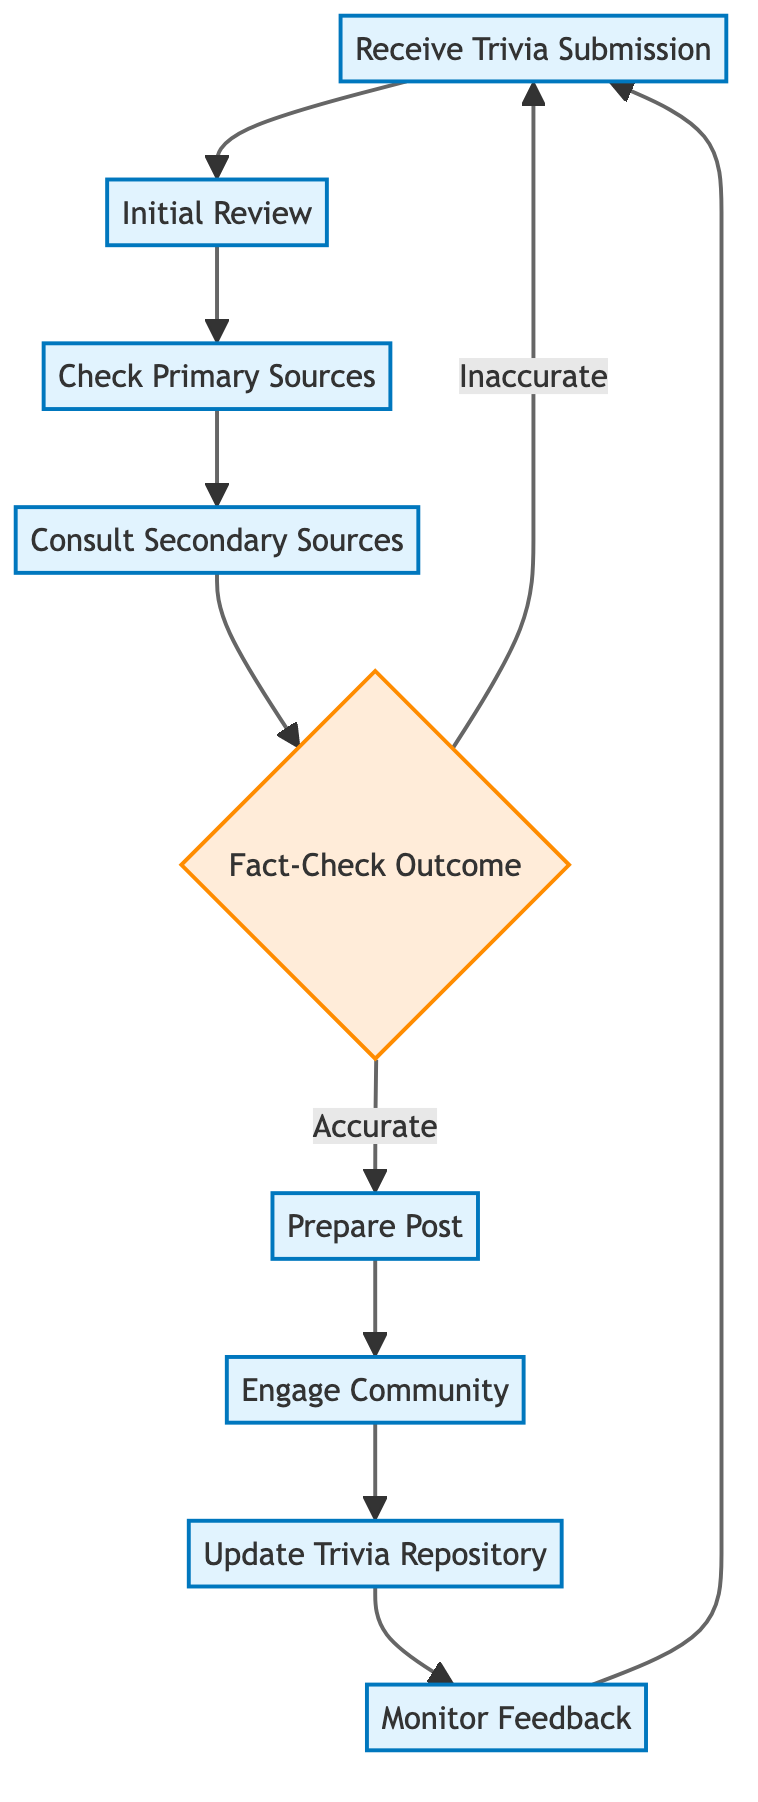What is the first step in the process? The first step in the process is "Receive Trivia Submission". This can be seen as the starting point in the flowchart where the process begins when moderators receive trivia submissions from forum members.
Answer: Receive Trivia Submission How many main process steps are there before the decision point? There are four main process steps before reaching the decision point labeled "Fact-Check Outcome". They are "Receive Trivia Submission", "Initial Review", "Check Primary Sources", and "Consult Secondary Sources".
Answer: Four What happens if the trivia submission is inaccurate? If the trivia submission is inaccurate, the flowchart indicates that the process loops back to "Receive Trivia Submission". This shows that moderators will provide feedback and request a resubmission from the member.
Answer: Return to Receive Trivia Submission What node follows "Prepare Post"? The node that follows "Prepare Post" is "Engage Community". This means after preparing the forum post, moderators will then engage with the community by posting the verified trivia.
Answer: Engage Community How many nodes represent the feedback process after trivia is posted to the forum? There are two nodes in the feedback process after posting to the forum: "Monitor Feedback" and back to "Receive Trivia Submission". This indicates ongoing engagement and feedback from community members.
Answer: Two What is the purpose of "Update Trivia Repository"? The purpose of "Update Trivia Repository" is to add verified trivia to a dedicated repository for easy reference by forum members. It represents the process of compiling verified trivia for future access.
Answer: Add to repository What is the final step in the diagram? The final step in the diagram, before looping back, is "Monitor Feedback". This indicates that after updating the trivia repository, the moderators will monitor any feedback from members to maintain engagement.
Answer: Monitor Feedback What type of flowchart is this diagram classified as? This diagram is classified as a flowchart of an instruction, illustrating the step-by-step process of fact-checking and sharing trivia. It visually represents the sequential flow of actions required.
Answer: Flowchart of an instruction 